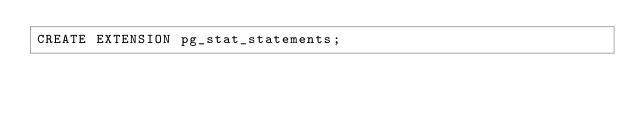Convert code to text. <code><loc_0><loc_0><loc_500><loc_500><_SQL_>CREATE EXTENSION pg_stat_statements;
</code> 